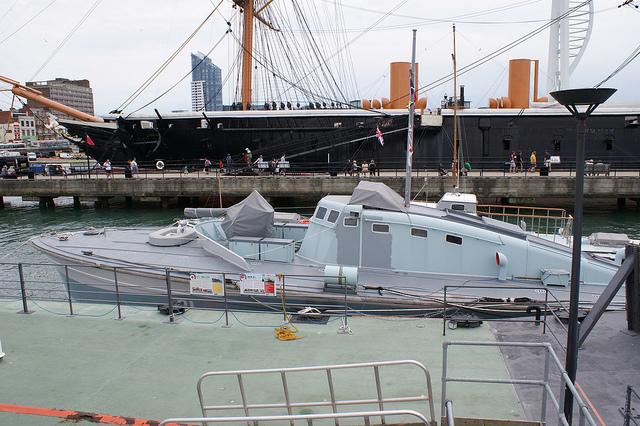Where is the big ship?
Quick response, please. Dock. How many boats are there?
Short answer required. 2. How many ships are seen?
Be succinct. 2. 